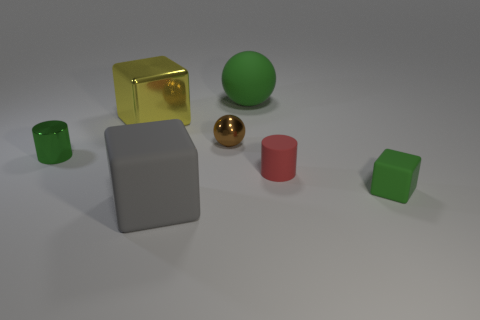Can you describe the arrangement and relative sizes of the objects in the image? Certainly! The objects are arranged on a flat surface with various distances between them. Starting from the left we have a small green cylinder, followed by a large grey cube at the center. In front of the cube, closer to us, sits a shiny golden sphere next to a brown ball. To the right of the central cube is a smaller red cylinder and a small green cube. The grey cube is the largest object, whereas the small green and red cylinders, along with the green cube, are the smallest. 